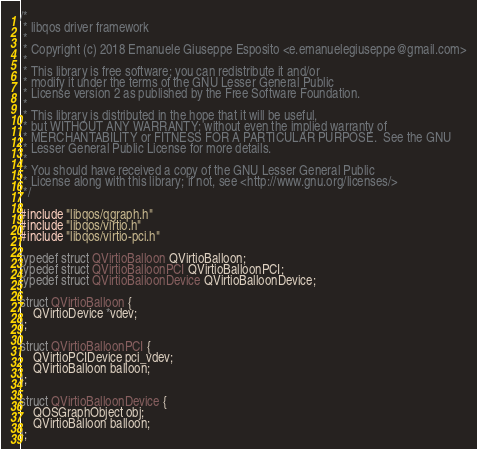Convert code to text. <code><loc_0><loc_0><loc_500><loc_500><_C_>/*
 * libqos driver framework
 *
 * Copyright (c) 2018 Emanuele Giuseppe Esposito <e.emanuelegiuseppe@gmail.com>
 *
 * This library is free software; you can redistribute it and/or
 * modify it under the terms of the GNU Lesser General Public
 * License version 2 as published by the Free Software Foundation.
 *
 * This library is distributed in the hope that it will be useful,
 * but WITHOUT ANY WARRANTY; without even the implied warranty of
 * MERCHANTABILITY or FITNESS FOR A PARTICULAR PURPOSE.  See the GNU
 * Lesser General Public License for more details.
 *
 * You should have received a copy of the GNU Lesser General Public
 * License along with this library; if not, see <http://www.gnu.org/licenses/>
 */

#include "libqos/qgraph.h"
#include "libqos/virtio.h"
#include "libqos/virtio-pci.h"

typedef struct QVirtioBalloon QVirtioBalloon;
typedef struct QVirtioBalloonPCI QVirtioBalloonPCI;
typedef struct QVirtioBalloonDevice QVirtioBalloonDevice;

struct QVirtioBalloon {
    QVirtioDevice *vdev;
};

struct QVirtioBalloonPCI {
    QVirtioPCIDevice pci_vdev;
    QVirtioBalloon balloon;
};

struct QVirtioBalloonDevice {
    QOSGraphObject obj;
    QVirtioBalloon balloon;
};
</code> 